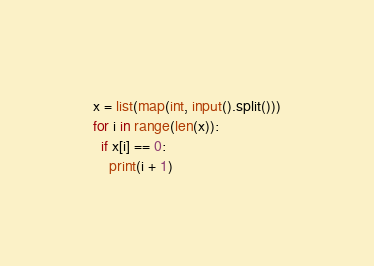<code> <loc_0><loc_0><loc_500><loc_500><_Python_>x = list(map(int, input().split()))
for i in range(len(x)):
  if x[i] == 0:
    print(i + 1)</code> 